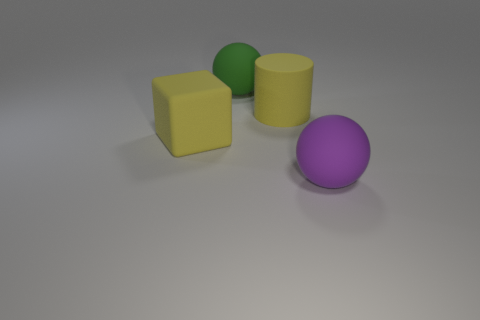Are there more purple objects than yellow matte objects?
Offer a very short reply. No. How many cyan matte blocks have the same size as the yellow cylinder?
Keep it short and to the point. 0. There is a big matte thing that is the same color as the big cylinder; what shape is it?
Your answer should be compact. Cube. What number of things are objects that are to the right of the green thing or large cyan metal things?
Make the answer very short. 2. Are there fewer yellow objects than large blocks?
Provide a short and direct response. No. There is a large green thing that is made of the same material as the large purple thing; what is its shape?
Provide a succinct answer. Sphere. There is a green thing; are there any big purple matte spheres in front of it?
Your answer should be very brief. Yes. Are there fewer yellow rubber cubes that are behind the yellow cube than small gray matte cubes?
Provide a short and direct response. No. What material is the large yellow cylinder?
Offer a very short reply. Rubber. The large cylinder has what color?
Your answer should be compact. Yellow. 